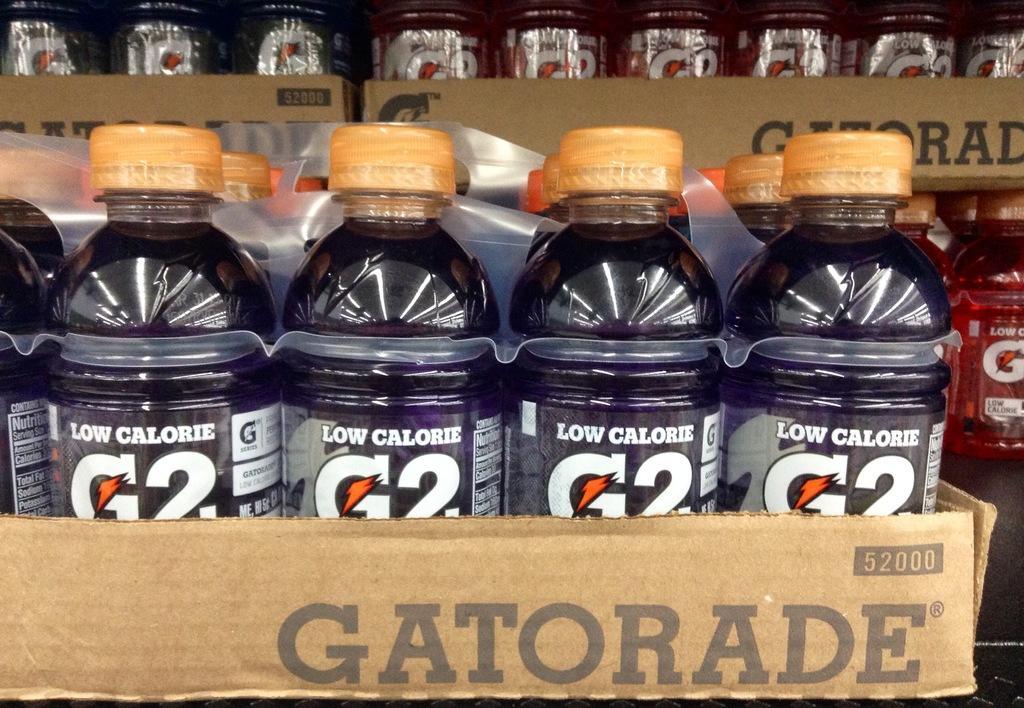Could you give a brief overview of what you see in this image? In this picture we can see bunch of bottles in the box. 